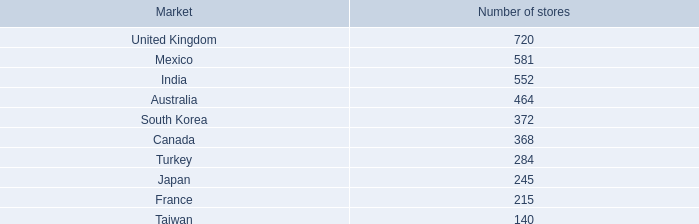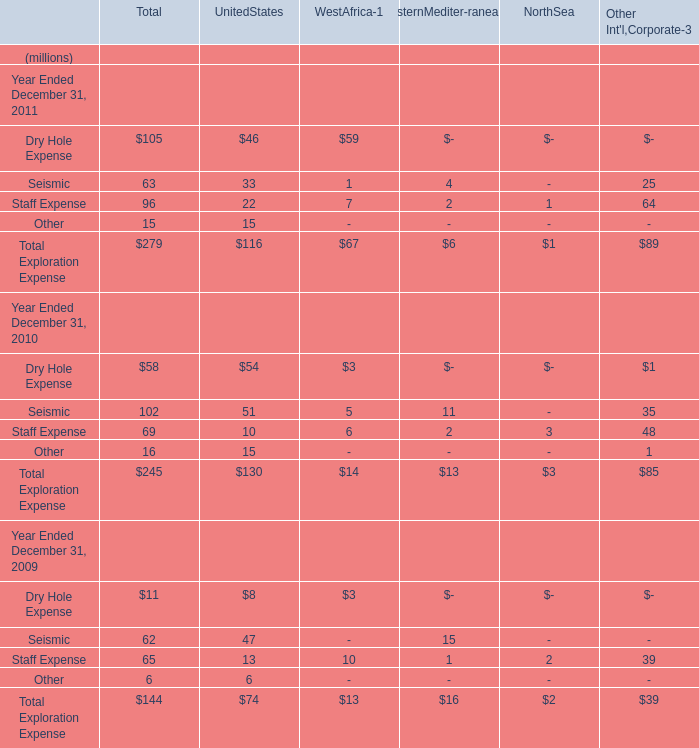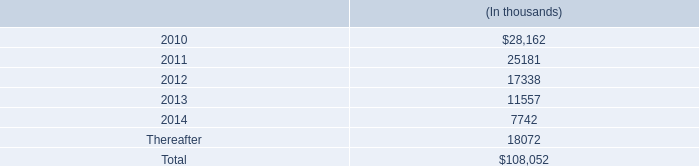What is the growth rate of Total Exploration Expense between 2010 and 2011 as Year is Ended December 31,in terms of Total? 
Computations: ((279 - 245) / 245)
Answer: 0.13878. 